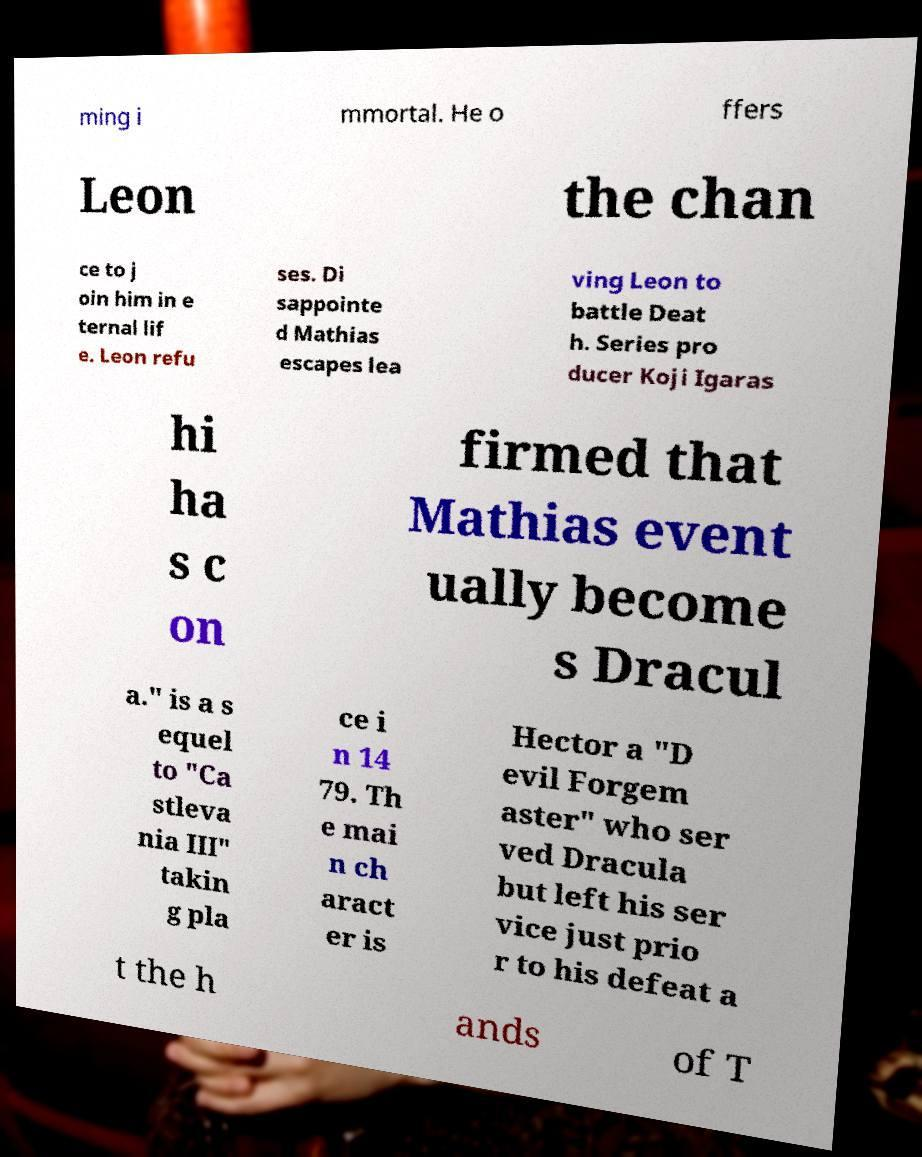Please read and relay the text visible in this image. What does it say? ming i mmortal. He o ffers Leon the chan ce to j oin him in e ternal lif e. Leon refu ses. Di sappointe d Mathias escapes lea ving Leon to battle Deat h. Series pro ducer Koji Igaras hi ha s c on firmed that Mathias event ually become s Dracul a." is a s equel to "Ca stleva nia III" takin g pla ce i n 14 79. Th e mai n ch aract er is Hector a "D evil Forgem aster" who ser ved Dracula but left his ser vice just prio r to his defeat a t the h ands of T 